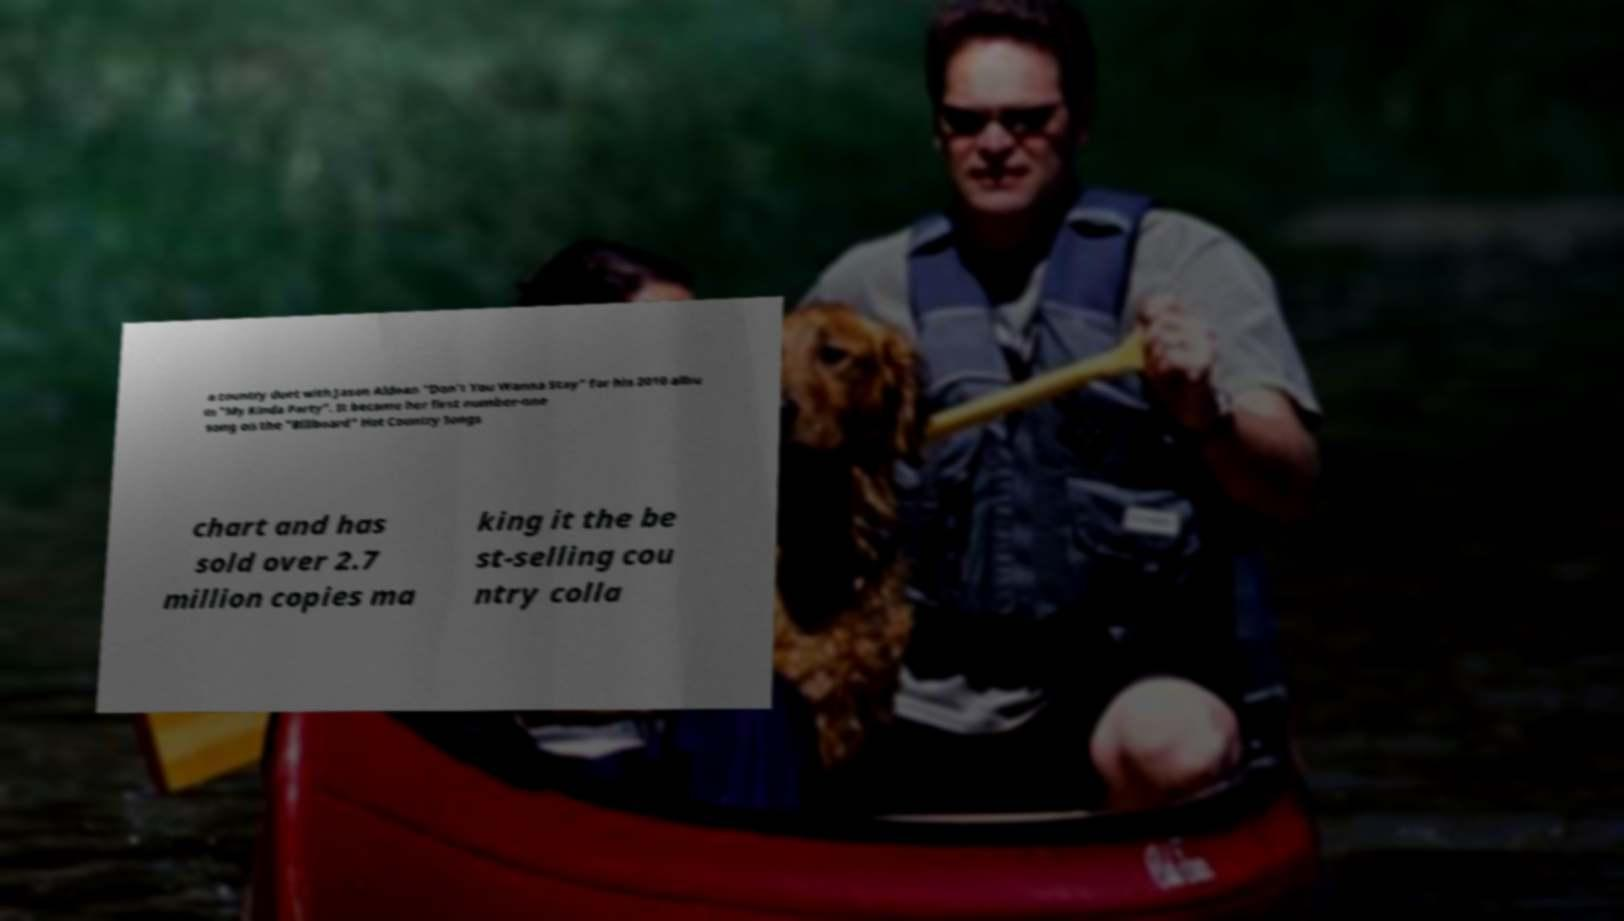Please read and relay the text visible in this image. What does it say? a country duet with Jason Aldean "Don't You Wanna Stay" for his 2010 albu m "My Kinda Party". It became her first number-one song on the "Billboard" Hot Country Songs chart and has sold over 2.7 million copies ma king it the be st-selling cou ntry colla 